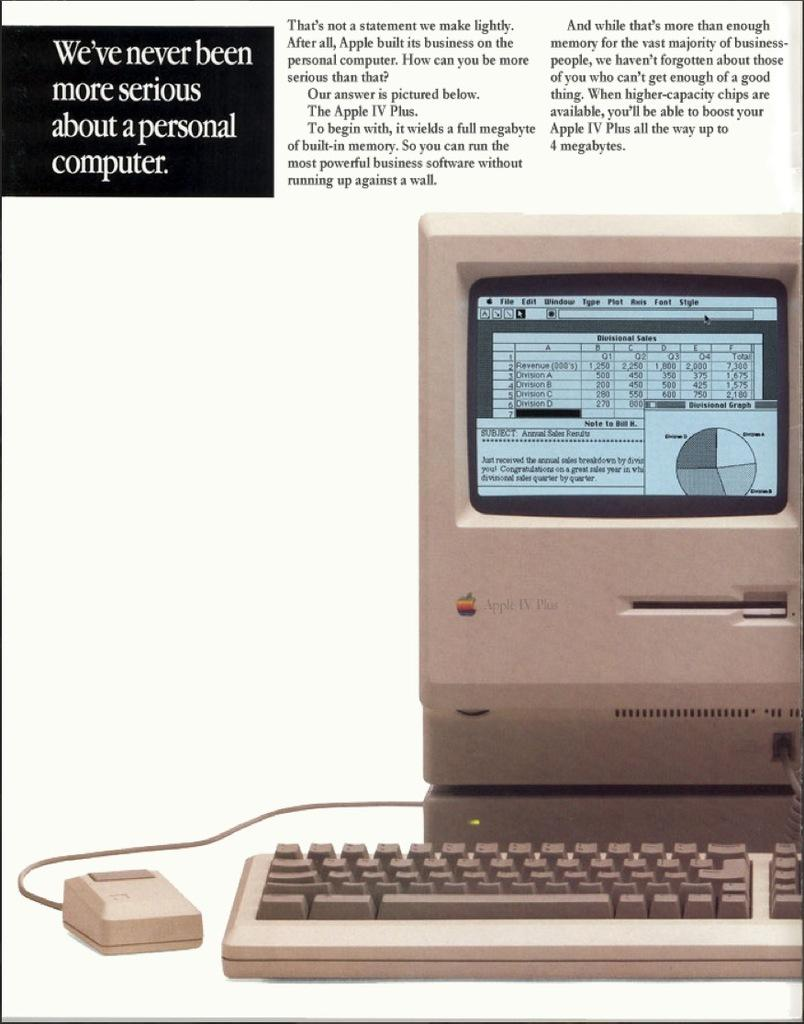<image>
Render a clear and concise summary of the photo. An old Apple IV Plus grey computer on a white background. 